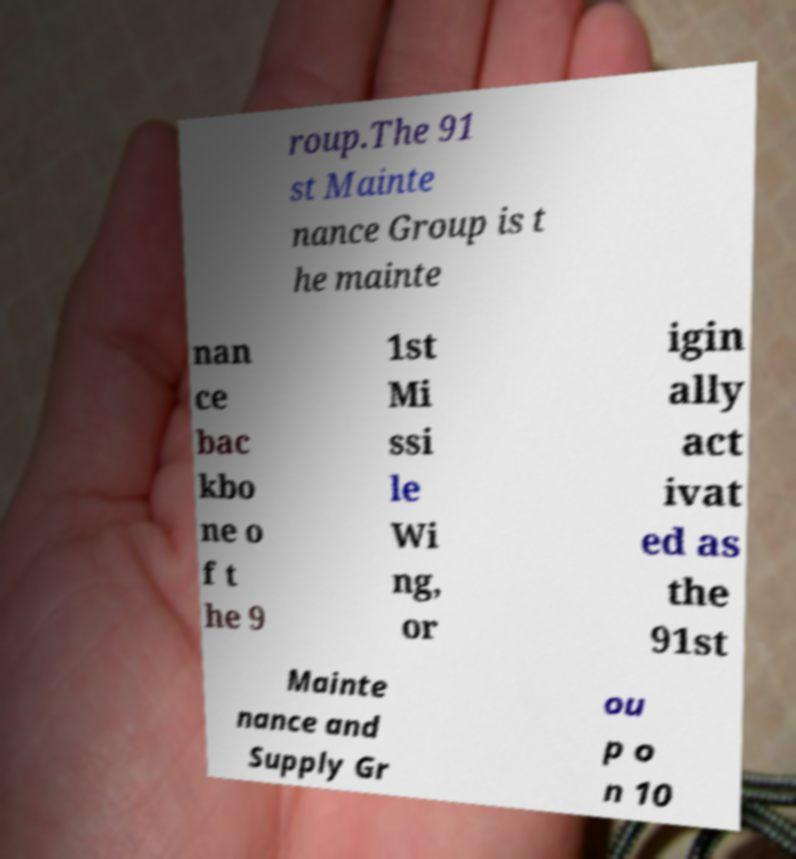Could you assist in decoding the text presented in this image and type it out clearly? roup.The 91 st Mainte nance Group is t he mainte nan ce bac kbo ne o f t he 9 1st Mi ssi le Wi ng, or igin ally act ivat ed as the 91st Mainte nance and Supply Gr ou p o n 10 